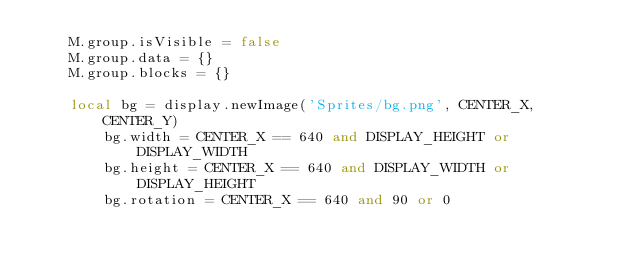Convert code to text. <code><loc_0><loc_0><loc_500><loc_500><_Lua_>    M.group.isVisible = false
    M.group.data = {}
    M.group.blocks = {}

    local bg = display.newImage('Sprites/bg.png', CENTER_X, CENTER_Y)
        bg.width = CENTER_X == 640 and DISPLAY_HEIGHT or DISPLAY_WIDTH
        bg.height = CENTER_X == 640 and DISPLAY_WIDTH or DISPLAY_HEIGHT
        bg.rotation = CENTER_X == 640 and 90 or 0</code> 